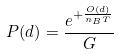Convert formula to latex. <formula><loc_0><loc_0><loc_500><loc_500>P ( d ) = \frac { e ^ { + \frac { O ( d ) } { n _ { B } T } } } { G }</formula> 